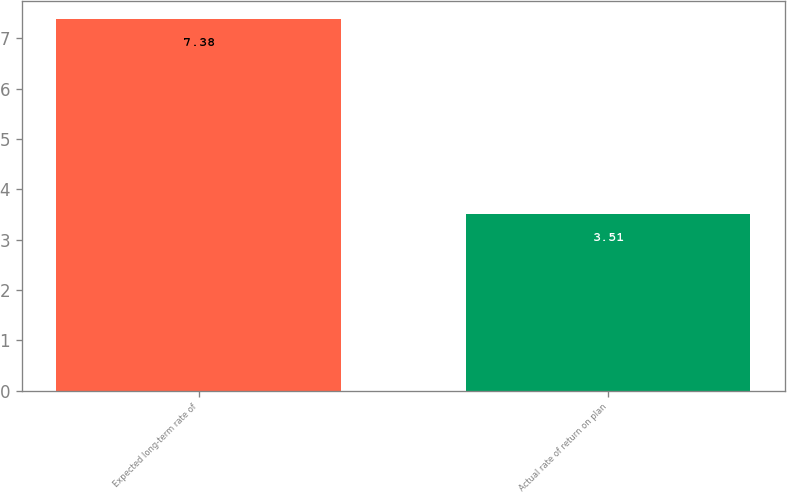Convert chart to OTSL. <chart><loc_0><loc_0><loc_500><loc_500><bar_chart><fcel>Expected long-term rate of<fcel>Actual rate of return on plan<nl><fcel>7.38<fcel>3.51<nl></chart> 